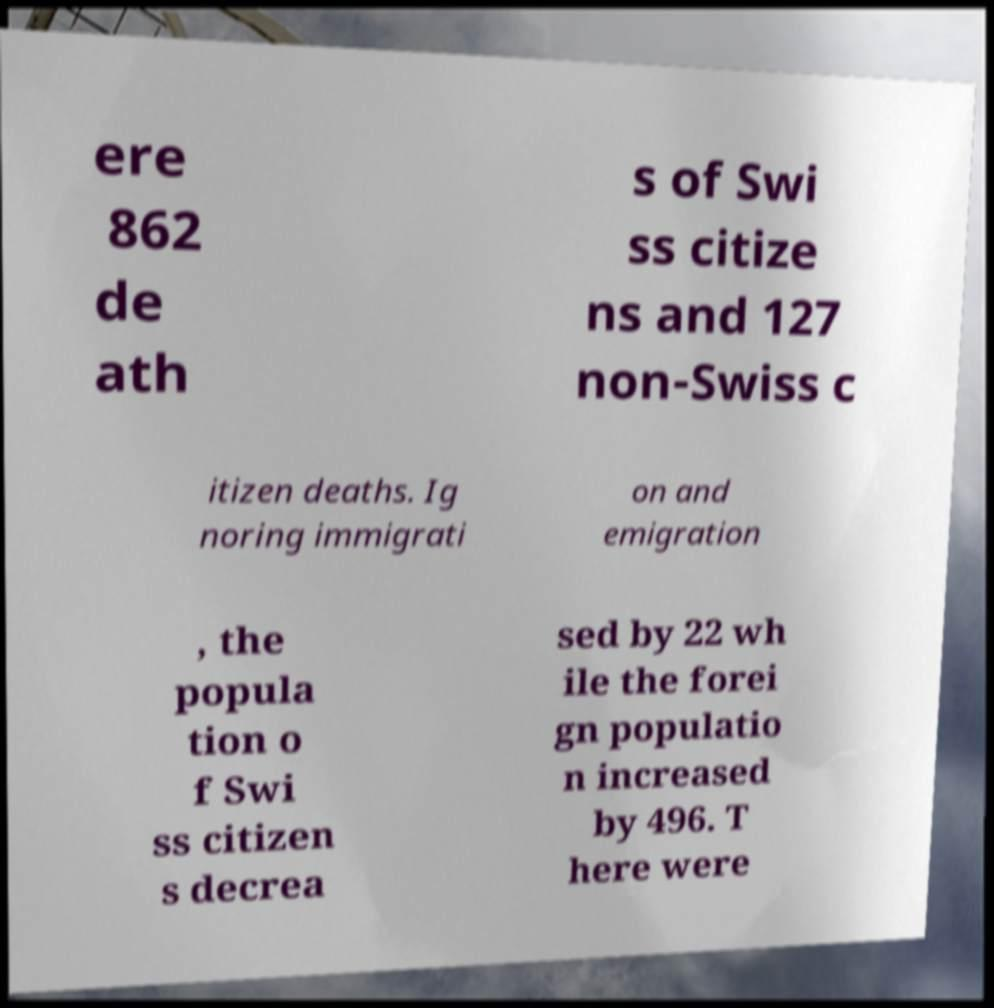I need the written content from this picture converted into text. Can you do that? ere 862 de ath s of Swi ss citize ns and 127 non-Swiss c itizen deaths. Ig noring immigrati on and emigration , the popula tion o f Swi ss citizen s decrea sed by 22 wh ile the forei gn populatio n increased by 496. T here were 